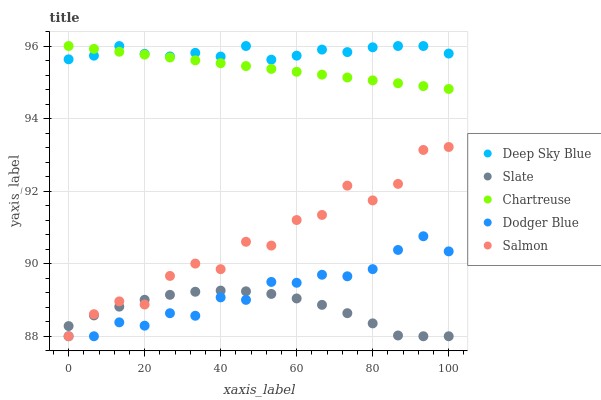Does Slate have the minimum area under the curve?
Answer yes or no. Yes. Does Deep Sky Blue have the maximum area under the curve?
Answer yes or no. Yes. Does Dodger Blue have the minimum area under the curve?
Answer yes or no. No. Does Dodger Blue have the maximum area under the curve?
Answer yes or no. No. Is Chartreuse the smoothest?
Answer yes or no. Yes. Is Salmon the roughest?
Answer yes or no. Yes. Is Slate the smoothest?
Answer yes or no. No. Is Slate the roughest?
Answer yes or no. No. Does Salmon have the lowest value?
Answer yes or no. Yes. Does Chartreuse have the lowest value?
Answer yes or no. No. Does Deep Sky Blue have the highest value?
Answer yes or no. Yes. Does Dodger Blue have the highest value?
Answer yes or no. No. Is Slate less than Deep Sky Blue?
Answer yes or no. Yes. Is Chartreuse greater than Slate?
Answer yes or no. Yes. Does Dodger Blue intersect Salmon?
Answer yes or no. Yes. Is Dodger Blue less than Salmon?
Answer yes or no. No. Is Dodger Blue greater than Salmon?
Answer yes or no. No. Does Slate intersect Deep Sky Blue?
Answer yes or no. No. 